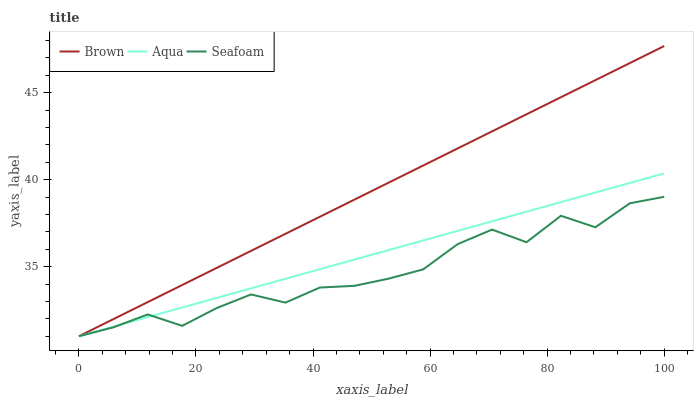Does Aqua have the minimum area under the curve?
Answer yes or no. No. Does Aqua have the maximum area under the curve?
Answer yes or no. No. Is Seafoam the smoothest?
Answer yes or no. No. Is Aqua the roughest?
Answer yes or no. No. Does Aqua have the highest value?
Answer yes or no. No. 